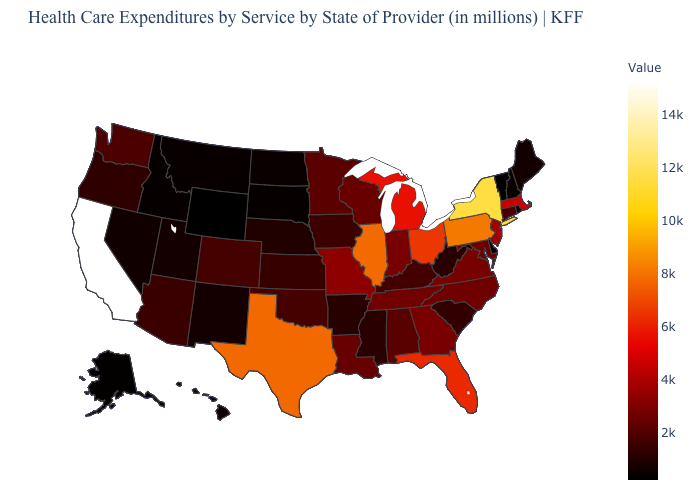Among the states that border Illinois , which have the highest value?
Quick response, please. Missouri. Is the legend a continuous bar?
Be succinct. Yes. Which states have the lowest value in the USA?
Keep it brief. Wyoming. Is the legend a continuous bar?
Answer briefly. Yes. Does the map have missing data?
Write a very short answer. No. Does Ohio have a lower value than New York?
Answer briefly. Yes. 